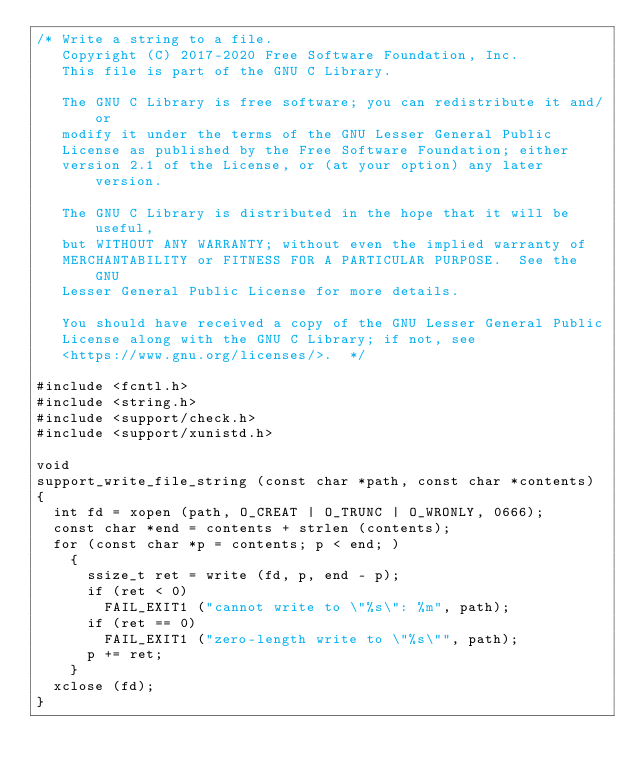<code> <loc_0><loc_0><loc_500><loc_500><_C_>/* Write a string to a file.
   Copyright (C) 2017-2020 Free Software Foundation, Inc.
   This file is part of the GNU C Library.

   The GNU C Library is free software; you can redistribute it and/or
   modify it under the terms of the GNU Lesser General Public
   License as published by the Free Software Foundation; either
   version 2.1 of the License, or (at your option) any later version.

   The GNU C Library is distributed in the hope that it will be useful,
   but WITHOUT ANY WARRANTY; without even the implied warranty of
   MERCHANTABILITY or FITNESS FOR A PARTICULAR PURPOSE.  See the GNU
   Lesser General Public License for more details.

   You should have received a copy of the GNU Lesser General Public
   License along with the GNU C Library; if not, see
   <https://www.gnu.org/licenses/>.  */

#include <fcntl.h>
#include <string.h>
#include <support/check.h>
#include <support/xunistd.h>

void
support_write_file_string (const char *path, const char *contents)
{
  int fd = xopen (path, O_CREAT | O_TRUNC | O_WRONLY, 0666);
  const char *end = contents + strlen (contents);
  for (const char *p = contents; p < end; )
    {
      ssize_t ret = write (fd, p, end - p);
      if (ret < 0)
        FAIL_EXIT1 ("cannot write to \"%s\": %m", path);
      if (ret == 0)
        FAIL_EXIT1 ("zero-length write to \"%s\"", path);
      p += ret;
    }
  xclose (fd);
}
</code> 